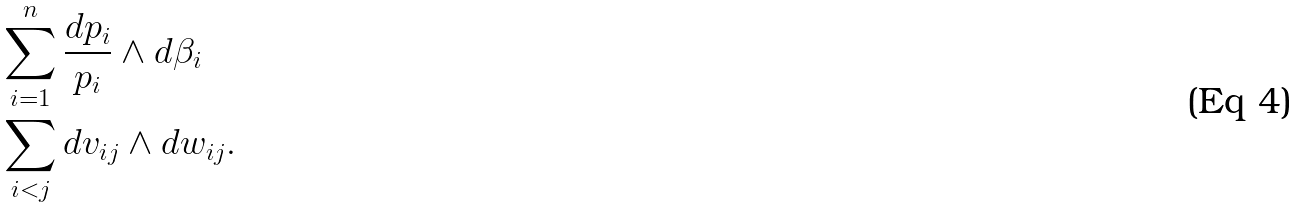<formula> <loc_0><loc_0><loc_500><loc_500>& \sum _ { i = 1 } ^ { n } \frac { d p _ { i } } { p _ { i } } \wedge d \beta _ { i } \\ & \sum _ { i < j } d v _ { i j } \wedge d w _ { i j } .</formula> 